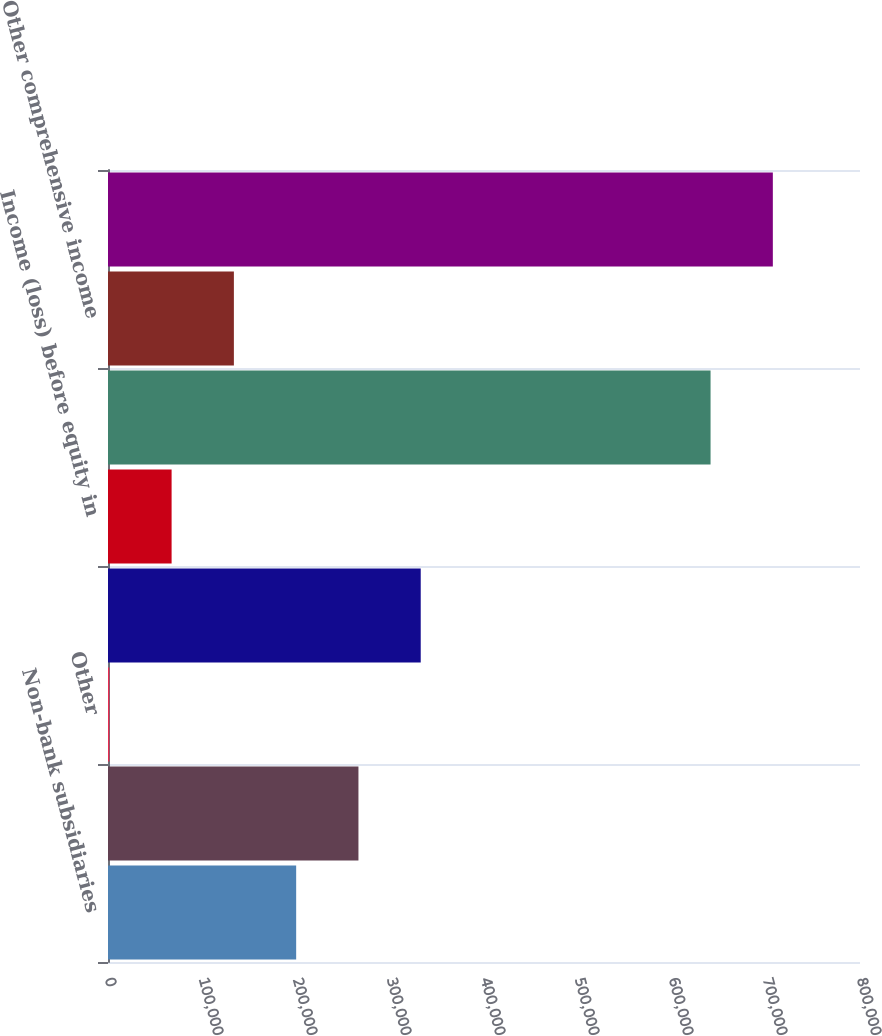<chart> <loc_0><loc_0><loc_500><loc_500><bar_chart><fcel>Non-bank subsidiaries<fcel>The Huntington National Bank<fcel>Other<fcel>Total income<fcel>Income (loss) before equity in<fcel>Net income<fcel>Other comprehensive income<fcel>Comprehensive income<nl><fcel>200177<fcel>266433<fcel>1409<fcel>332688<fcel>67664.9<fcel>641022<fcel>133921<fcel>707278<nl></chart> 